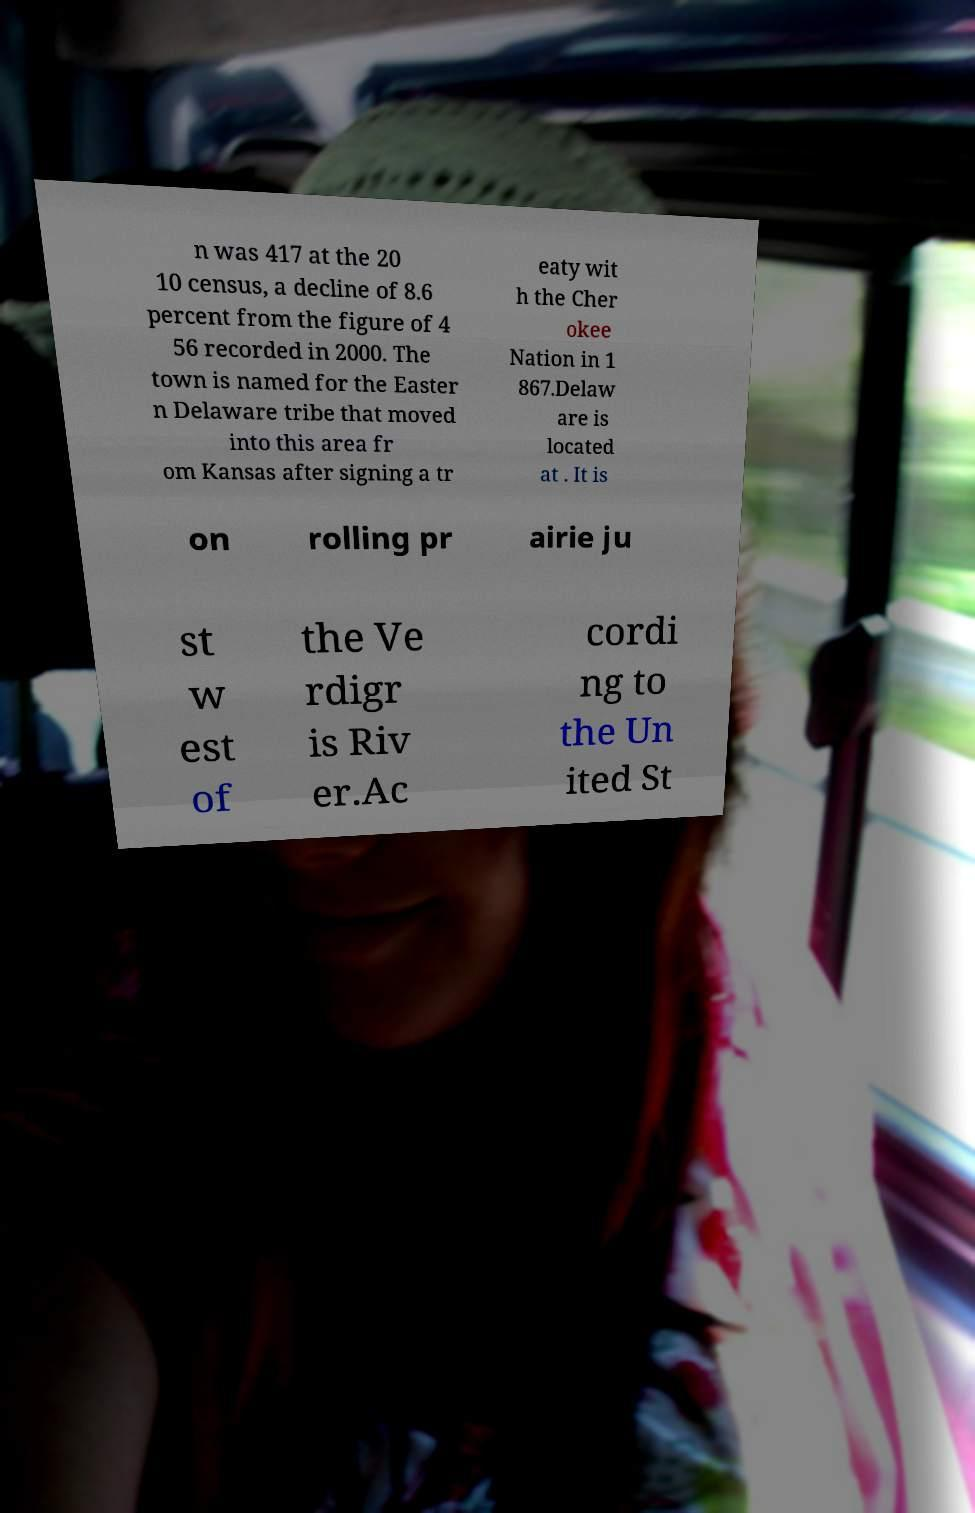Please read and relay the text visible in this image. What does it say? n was 417 at the 20 10 census, a decline of 8.6 percent from the figure of 4 56 recorded in 2000. The town is named for the Easter n Delaware tribe that moved into this area fr om Kansas after signing a tr eaty wit h the Cher okee Nation in 1 867.Delaw are is located at . It is on rolling pr airie ju st w est of the Ve rdigr is Riv er.Ac cordi ng to the Un ited St 